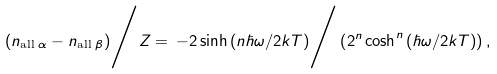Convert formula to latex. <formula><loc_0><loc_0><loc_500><loc_500>( n _ { \text {all\ } \alpha } - n _ { \text {all\ } \beta } ) \Big / Z = \, { - 2 \sinh { ( n \hbar { \omega } / 2 k T ) } } \Big / \left ( 2 ^ { n } \cosh ^ { n } { ( \hbar { \omega } / 2 k T ) } \right ) ,</formula> 